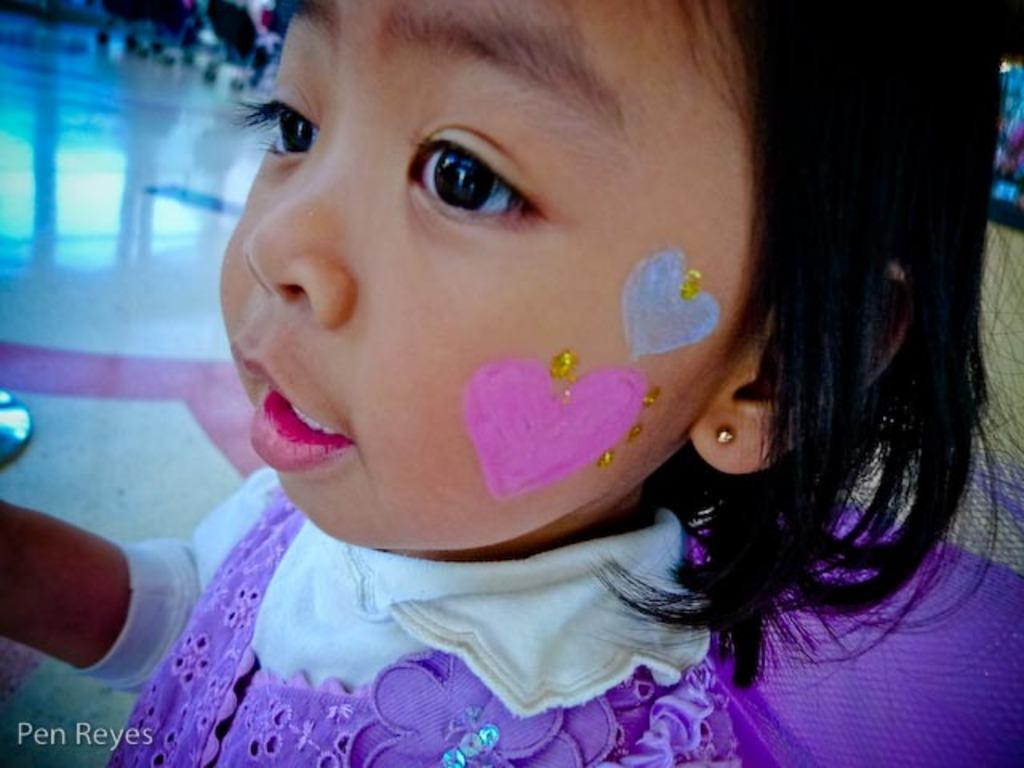Who is the main subject in the picture? There is a girl in the picture. What is on the girl's face? There is paint on the girl's face. In which direction is the girl looking? The girl is looking to the left. What can be seen in the background of the picture? There are trolleys in the backdrop of the picture. How is the backdrop of the picture depicted? The backdrop is blurred. What type of plant can be seen growing in the girl's hair in the image? There is no plant visible in the girl's hair in the image. How does the society depicted in the image react to the girl's painted face? The image does not show any society or reaction to the girl's painted face; it only depicts the girl and the background. 